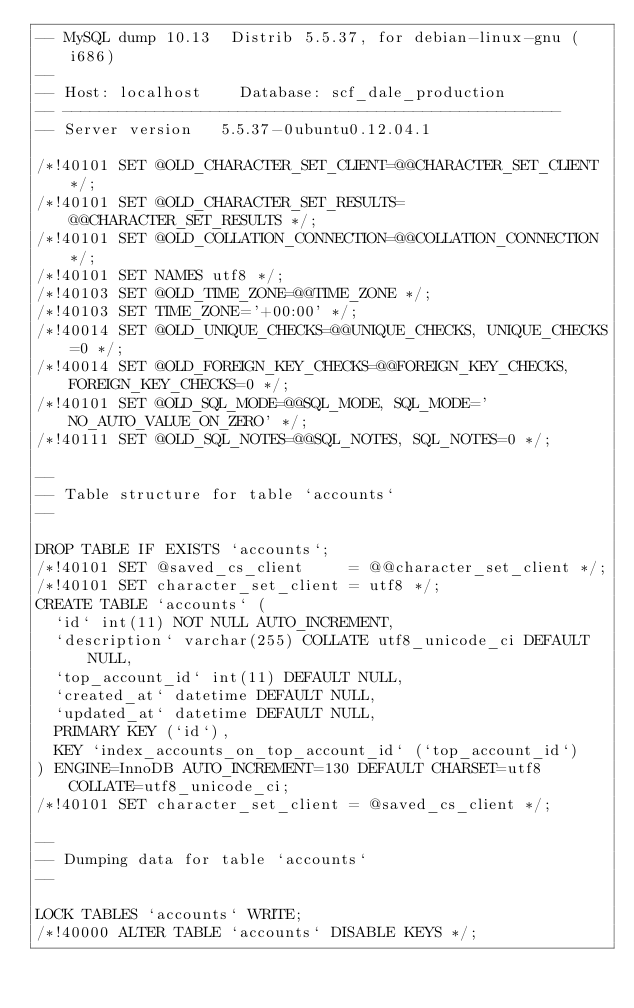Convert code to text. <code><loc_0><loc_0><loc_500><loc_500><_SQL_>-- MySQL dump 10.13  Distrib 5.5.37, for debian-linux-gnu (i686)
--
-- Host: localhost    Database: scf_dale_production
-- ------------------------------------------------------
-- Server version	5.5.37-0ubuntu0.12.04.1

/*!40101 SET @OLD_CHARACTER_SET_CLIENT=@@CHARACTER_SET_CLIENT */;
/*!40101 SET @OLD_CHARACTER_SET_RESULTS=@@CHARACTER_SET_RESULTS */;
/*!40101 SET @OLD_COLLATION_CONNECTION=@@COLLATION_CONNECTION */;
/*!40101 SET NAMES utf8 */;
/*!40103 SET @OLD_TIME_ZONE=@@TIME_ZONE */;
/*!40103 SET TIME_ZONE='+00:00' */;
/*!40014 SET @OLD_UNIQUE_CHECKS=@@UNIQUE_CHECKS, UNIQUE_CHECKS=0 */;
/*!40014 SET @OLD_FOREIGN_KEY_CHECKS=@@FOREIGN_KEY_CHECKS, FOREIGN_KEY_CHECKS=0 */;
/*!40101 SET @OLD_SQL_MODE=@@SQL_MODE, SQL_MODE='NO_AUTO_VALUE_ON_ZERO' */;
/*!40111 SET @OLD_SQL_NOTES=@@SQL_NOTES, SQL_NOTES=0 */;

--
-- Table structure for table `accounts`
--

DROP TABLE IF EXISTS `accounts`;
/*!40101 SET @saved_cs_client     = @@character_set_client */;
/*!40101 SET character_set_client = utf8 */;
CREATE TABLE `accounts` (
  `id` int(11) NOT NULL AUTO_INCREMENT,
  `description` varchar(255) COLLATE utf8_unicode_ci DEFAULT NULL,
  `top_account_id` int(11) DEFAULT NULL,
  `created_at` datetime DEFAULT NULL,
  `updated_at` datetime DEFAULT NULL,
  PRIMARY KEY (`id`),
  KEY `index_accounts_on_top_account_id` (`top_account_id`)
) ENGINE=InnoDB AUTO_INCREMENT=130 DEFAULT CHARSET=utf8 COLLATE=utf8_unicode_ci;
/*!40101 SET character_set_client = @saved_cs_client */;

--
-- Dumping data for table `accounts`
--

LOCK TABLES `accounts` WRITE;
/*!40000 ALTER TABLE `accounts` DISABLE KEYS */;</code> 